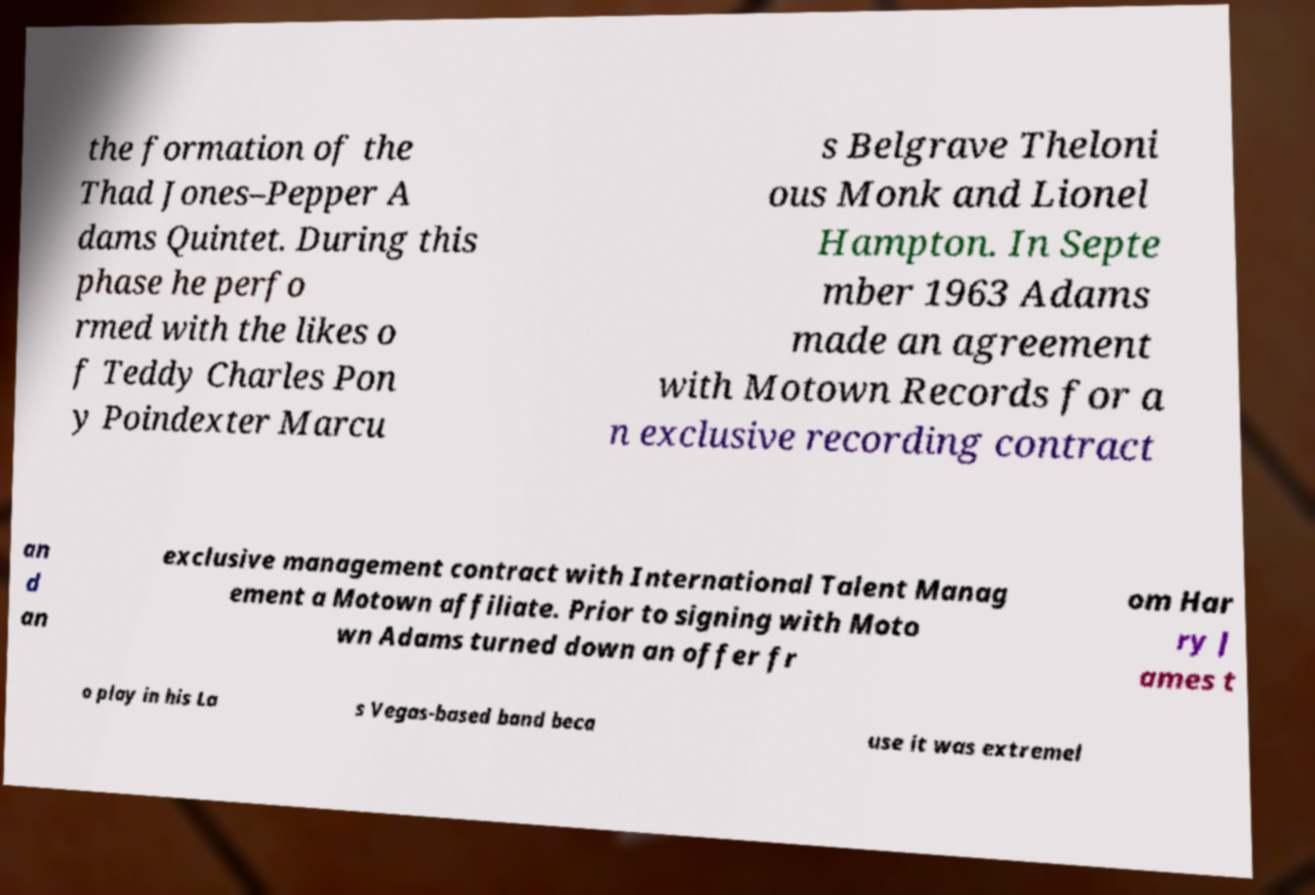For documentation purposes, I need the text within this image transcribed. Could you provide that? the formation of the Thad Jones–Pepper A dams Quintet. During this phase he perfo rmed with the likes o f Teddy Charles Pon y Poindexter Marcu s Belgrave Theloni ous Monk and Lionel Hampton. In Septe mber 1963 Adams made an agreement with Motown Records for a n exclusive recording contract an d an exclusive management contract with International Talent Manag ement a Motown affiliate. Prior to signing with Moto wn Adams turned down an offer fr om Har ry J ames t o play in his La s Vegas-based band beca use it was extremel 